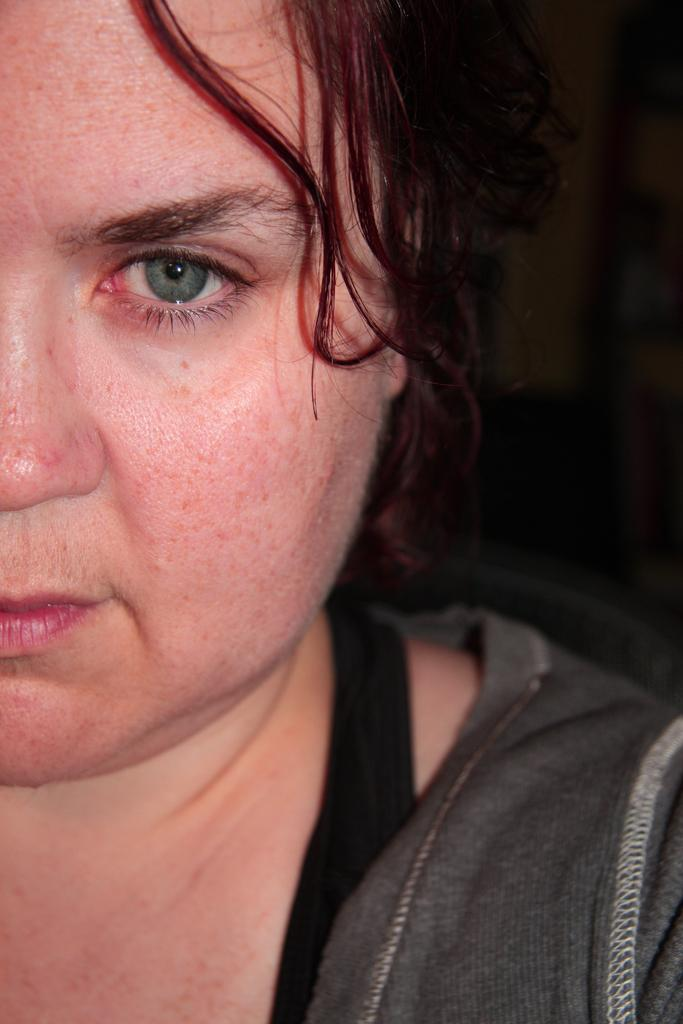Who is the main subject in the image? There is a woman in the image. What is the woman wearing? The woman is wearing a grey dress. Can you describe the background of the image? The background of the image is blurry. What type of rock is the woman holding in the image? There is no rock present in the image; the woman is not holding anything. 